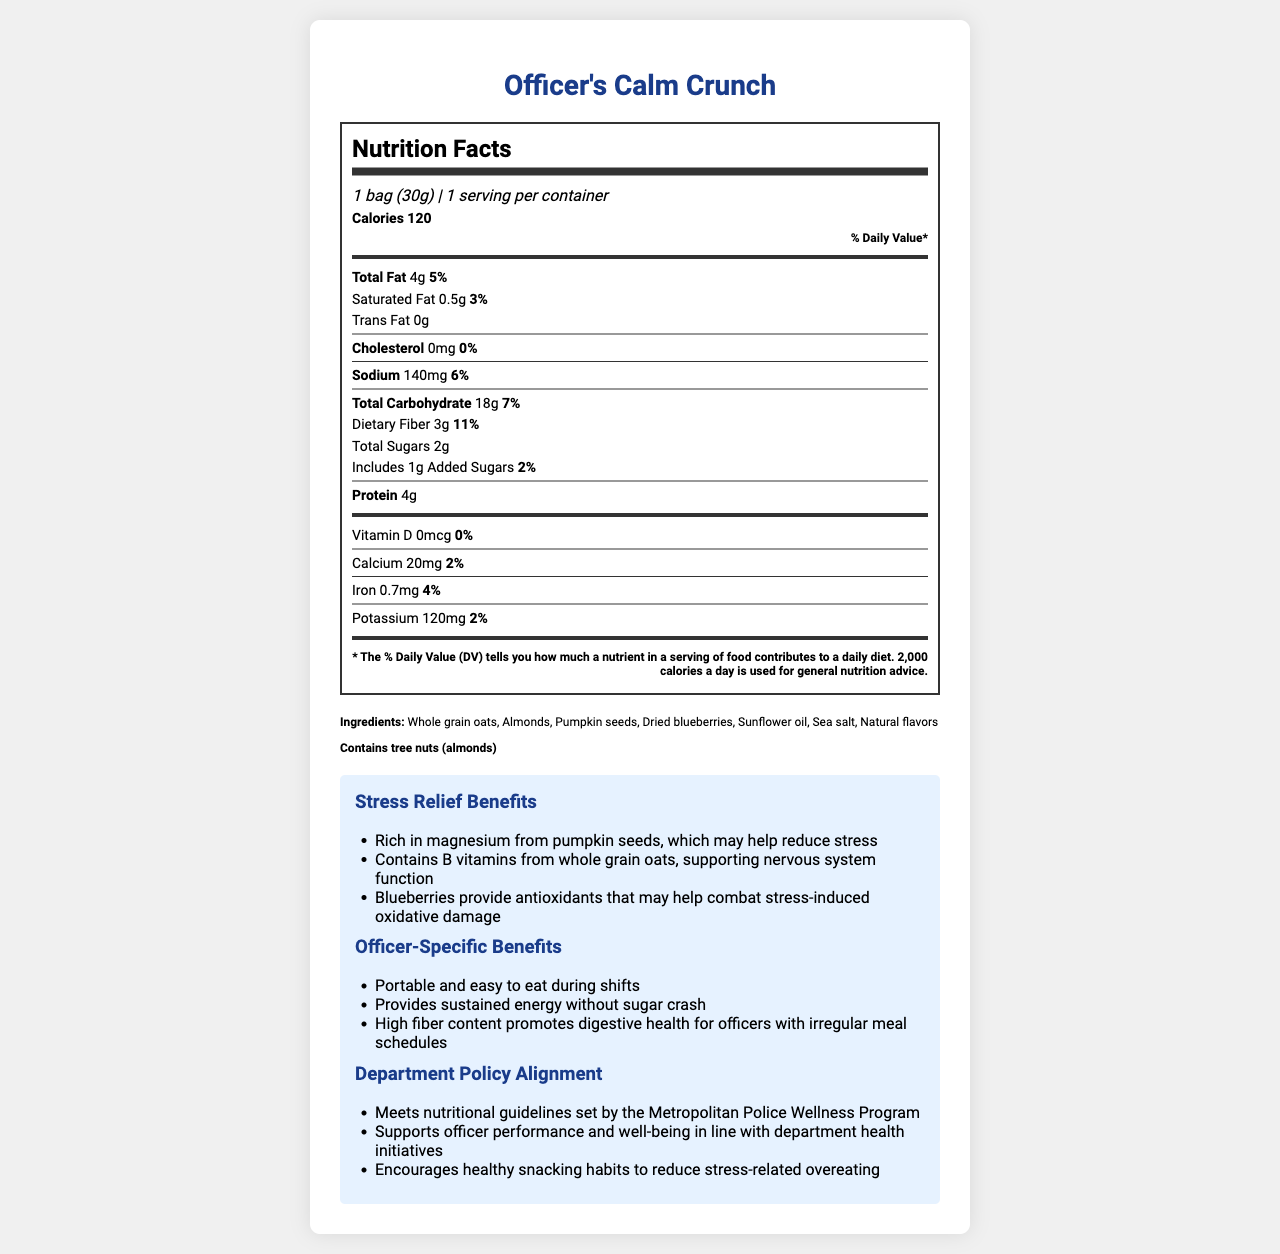what is the calorie count per serving? The document states that the calorie count per serving is 120.
Answer: 120 calories how much fiber is in one serving of Officer's Calm Crunch? The nutritional label lists dietary fiber content as 3 grams.
Answer: 3 grams how many servings are there per container? The document mentions that there is 1 serving per container.
Answer: 1 serving what percentage of the daily value of dietary fiber does one serving provide? The document states that one serving provides 11% of the daily value of dietary fiber.
Answer: 11% list three main stress-relief benefits of Officer's Calm Crunch. These benefits are listed under the "Stress Relief Benefits" section of the document.
Answer: - Rich in magnesium from pumpkin seeds, which may help reduce stress
- Contains B vitamins from whole grain oats, supporting nervous system function
- Blueberries provide antioxidants that may help combat stress-induced oxidative damage how much protein is in one serving? A. 2 grams B. 3 grams C. 4 grams D. 5 grams The document states that there are 4 grams of protein in one serving.
Answer: C. 4 grams what is the main ingredient in Officer's Calm Crunch? A. Almonds B. Whole grain oats C. Dried blueberries D. Sunflower oil The first ingredient listed is whole grain oats, indicating it is the main ingredient.
Answer: B. Whole grain oats is there any cholesterol in Officer's Calm Crunch? The document lists the cholesterol content as 0 mg.
Answer: No does the product contain any allergens? The document mentions that the product contains tree nuts (almonds).
Answer: Yes describe the main purpose and benefits of Officer's Calm Crunch for officers. This summary incorporates all the main information and benefits provided in the document.
Answer: Officer's Calm Crunch is a stress-relief snack designed for police officers. It contains ingredients like whole grain oats, almonds, pumpkin seeds, and dried blueberries that help reduce stress through their nutritional components, such as magnesium, B vitamins, and antioxidants. The snack is portable and easy to eat during shifts, provides sustained energy without causing a sugar crash, and has high fiber content to promote digestive health, which is particularly beneficial for officers with irregular meal schedules. It aligns with the Metropolitan Police Wellness Program guidelines and supports officer performance and well-being. what are the B vitamins present in whole grain oats? The document mentions the presence of B vitamins but does not specify which B vitamins are present in whole grain oats.
Answer: Not enough information 